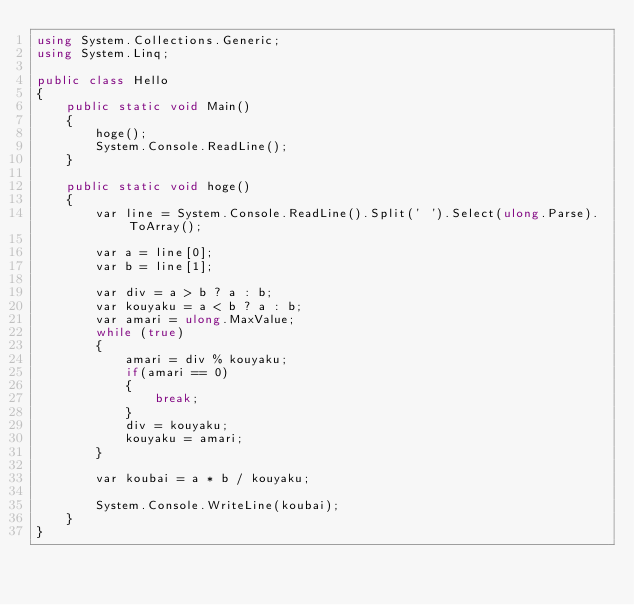<code> <loc_0><loc_0><loc_500><loc_500><_C#_>using System.Collections.Generic;
using System.Linq;

public class Hello
{
    public static void Main()
    {
        hoge();
        System.Console.ReadLine();
    }

    public static void hoge()
    {
        var line = System.Console.ReadLine().Split(' ').Select(ulong.Parse).ToArray();

        var a = line[0];
        var b = line[1];

        var div = a > b ? a : b;
        var kouyaku = a < b ? a : b;
        var amari = ulong.MaxValue;
        while (true)
        {
            amari = div % kouyaku;
            if(amari == 0)
            {
                break;
            }
            div = kouyaku;
            kouyaku = amari;
        }

        var koubai = a * b / kouyaku;

        System.Console.WriteLine(koubai);
    }
}

</code> 